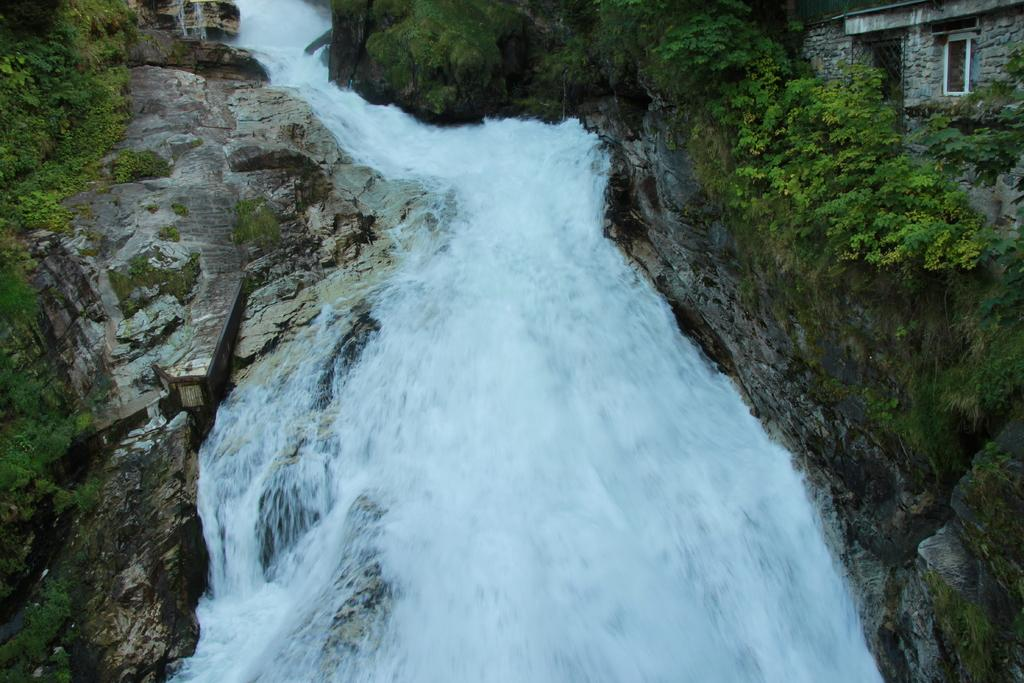What is the main feature in the middle of the image? There is a waterfall in the middle of the image. What can be seen on either side of the waterfall? There are plants on either side of the waterfall. Where are the plants located? The plants are on rocks. What type of pie is being served at the club near the waterfall in the image? There is no mention of a club or pie in the image; it features a waterfall with plants on rocks. 